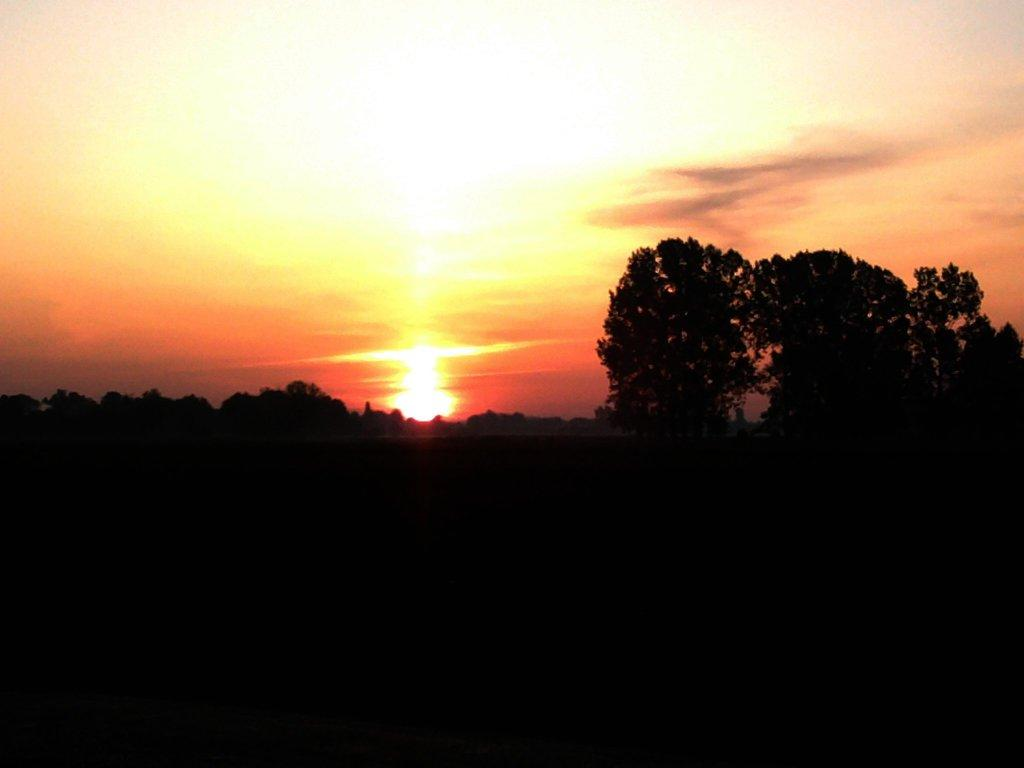What is the main subject of the dark picture in the image? There is a dark picture of a plant in the image. What other natural elements can be seen in the image? There are trees in the image. What is visible in the sky in the image? The sky is visible in the image, and it contains sunshine and clouds. Can you tell me how many goldfish are swimming in the school depicted in the image? There is no school or goldfish present in the image; it features a dark picture of a plant, trees, and a sky with sunshine and clouds. 